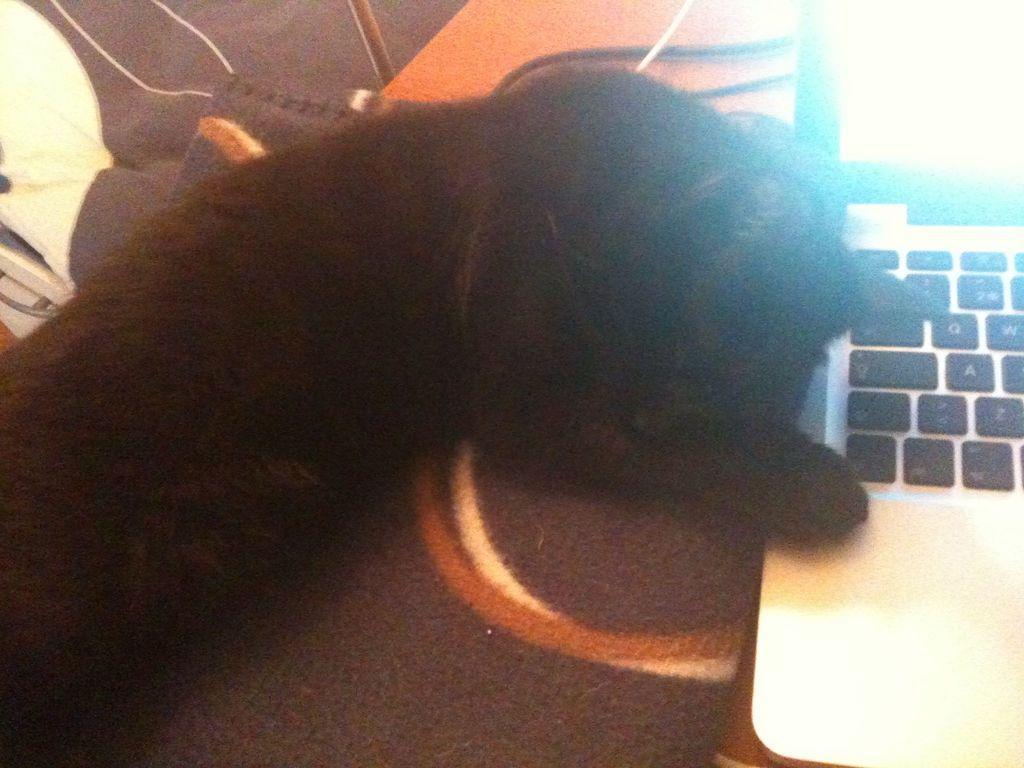In one or two sentences, can you explain what this image depicts? In this image we can see a dog and a laptop on the surface. 